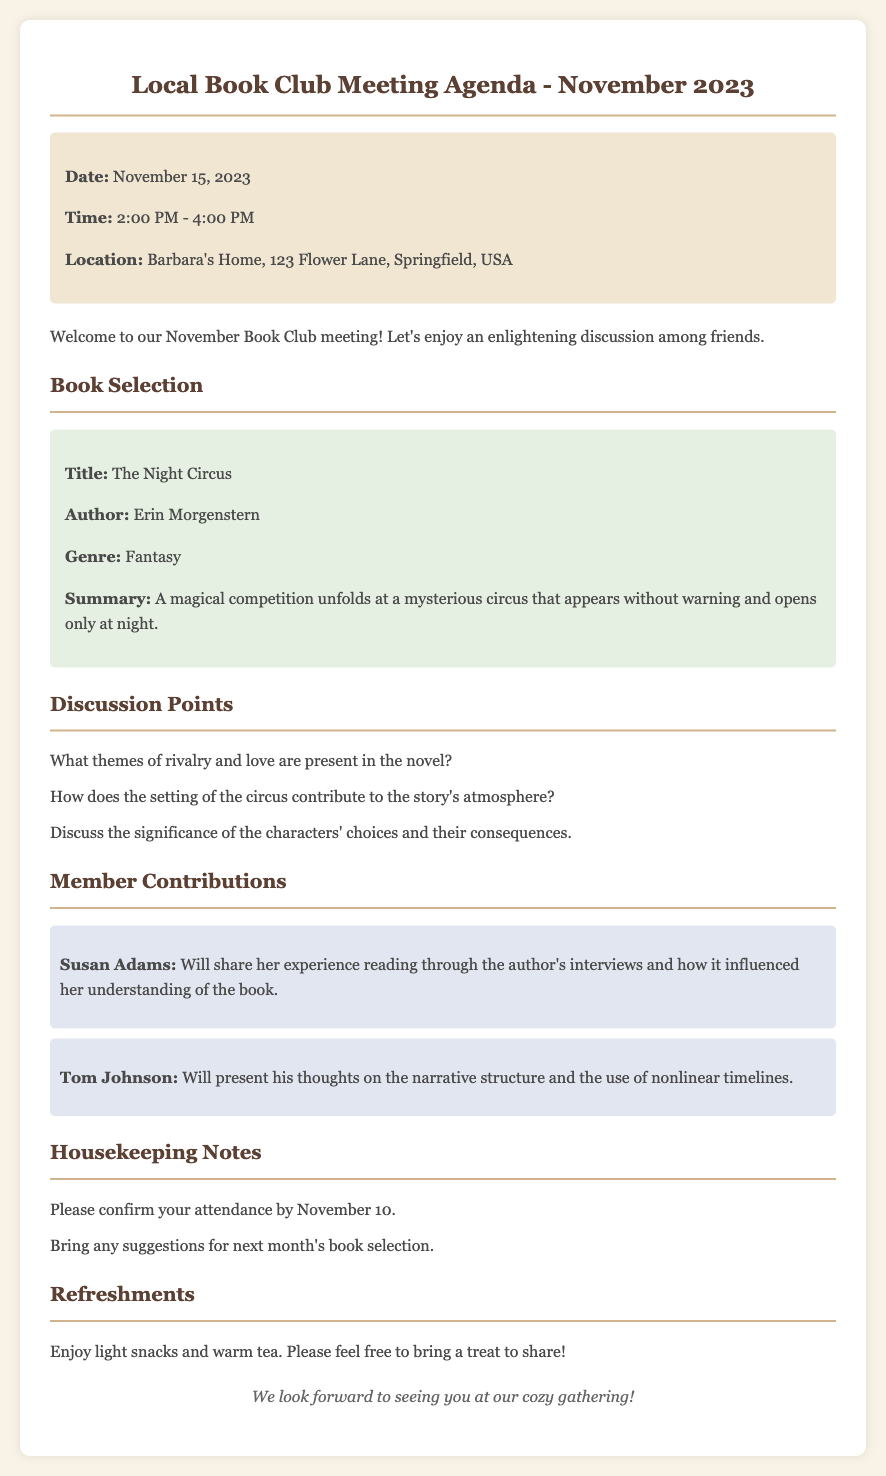What is the date of the meeting? The date of the meeting is specified in the document as November 15, 2023.
Answer: November 15, 2023 What time is the meeting scheduled to start? The document states that the meeting will begin at 2:00 PM.
Answer: 2:00 PM Who is the author of "The Night Circus"? The author of the book is mentioned in the book selection section of the document as Erin Morgenstern.
Answer: Erin Morgenstern What are participants encouraged to bring for next month's book selection? The document suggests that members should bring suggestions for next month's book selection.
Answer: Suggestions for next month's book What significant theme is to be discussed in the meeting? One of the discussion points highlights rivalry and love as significant themes in "The Night Circus."
Answer: Rivalry and love Who will share insights from the author's interviews? The document specifies that Susan Adams will share her experiences regarding the author's interviews.
Answer: Susan Adams What type of refreshments will be available at the meeting? The document indicates that light snacks and warm tea will be provided as refreshments.
Answer: Light snacks and warm tea What is the location of the meeting? The document provides the location as Barbara's Home, 123 Flower Lane, Springfield, USA.
Answer: Barbara's Home, 123 Flower Lane, Springfield, USA How many narrative structures will Tom Johnson discuss? Tom Johnson will present his thoughts on the narrative structure regarding the narrative structure's specifics mentioned in the document.
Answer: One narrative structure 